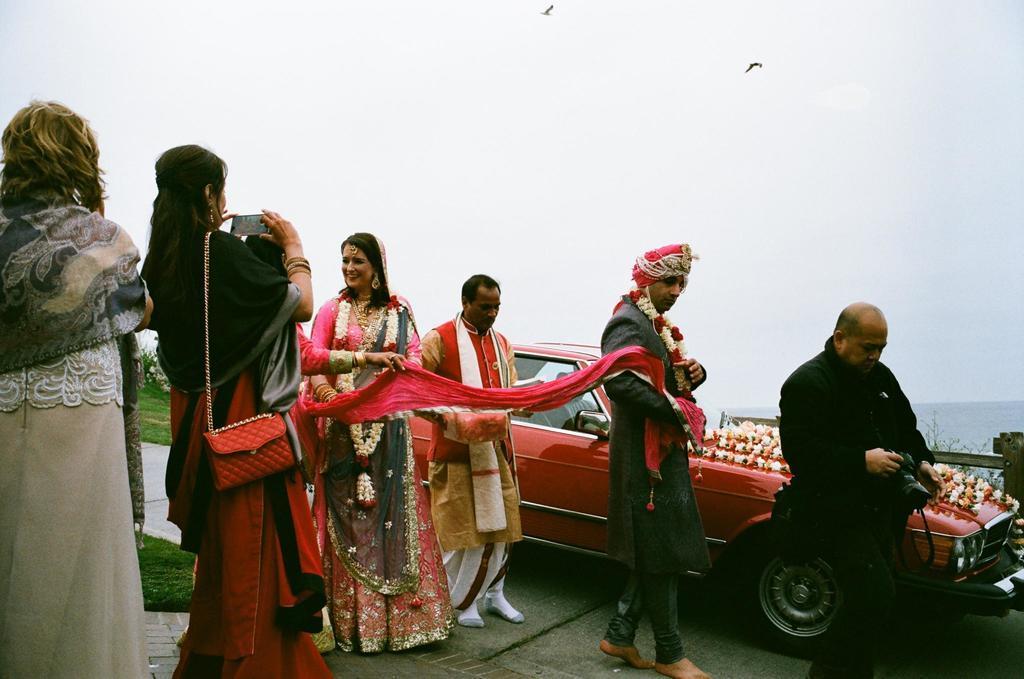In one or two sentences, can you explain what this image depicts? In this image there are few people beside the car in which one of them holding a bag, mobile phone and capturing a photo, there are birds flying in the sky, trees, plants, grass and the water. 